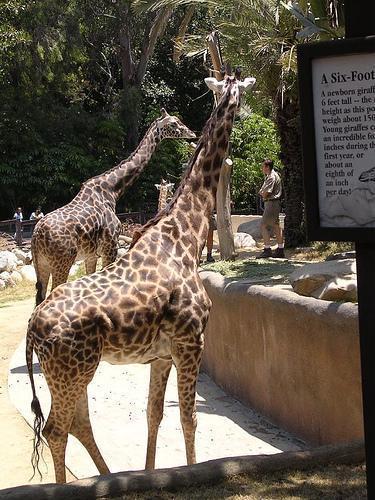How many animals are there?
Give a very brief answer. 3. How many giraffes are there?
Give a very brief answer. 2. How many chairs are there?
Give a very brief answer. 0. 